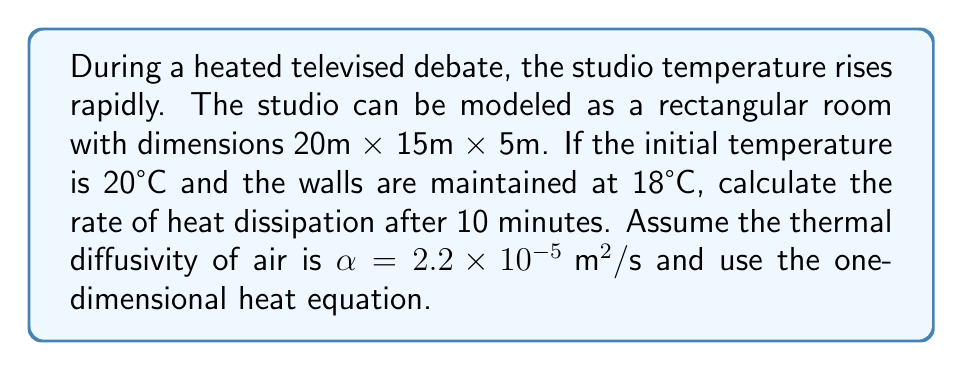Solve this math problem. 1) The one-dimensional heat equation is:

   $$\frac{\partial u}{\partial t} = \alpha \frac{\partial^2 u}{\partial x^2}$$

2) The solution for a rectangular room with constant boundary conditions is:

   $$u(x,t) = u_s + \sum_{n=1}^{\infty} B_n \sin(\frac{n\pi x}{L}) e^{-\alpha (\frac{n\pi}{L})^2 t}$$

   where $u_s$ is the steady-state temperature (wall temperature), $L$ is the room width, and:

   $$B_n = \frac{2}{L} \int_0^L (u_0 - u_s) \sin(\frac{n\pi x}{L}) dx$$

3) For simplicity, we'll consider the width direction (20m). Initially, $u_0 = 20°C$ and $u_s = 18°C$. 

4) Calculating $B_n$:

   $$B_n = \frac{2}{20} \int_0^{20} 2 \sin(\frac{n\pi x}{20}) dx = \frac{4}{n\pi} (1 - \cos(n\pi))$$

5) The temperature distribution after time $t$ is:

   $$u(x,t) = 18 + \sum_{n=1}^{\infty} \frac{4}{n\pi} (1 - \cos(n\pi)) \sin(\frac{n\pi x}{20}) e^{-2.2 \times 10^{-5} (\frac{n\pi}{20})^2 t}$$

6) The rate of heat dissipation is proportional to the rate of temperature change:

   $$\frac{\partial u}{\partial t} = -\sum_{n=1}^{\infty} \frac{4}{n\pi} (1 - \cos(n\pi)) \sin(\frac{n\pi x}{20}) \cdot 2.2 \times 10^{-5} (\frac{n\pi}{20})^2 e^{-2.2 \times 10^{-5} (\frac{n\pi}{20})^2 t}$$

7) At $t = 600s$ (10 minutes), evaluating at the center of the room ($x = 10$):

   $$\frac{\partial u}{\partial t} \approx -0.0033 °C/s$$

8) This rate applies to the entire volume of the studio.
Answer: $-0.0033 °C/s$ 